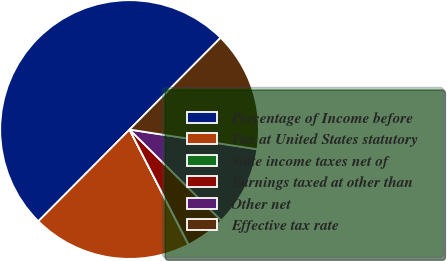Convert chart to OTSL. <chart><loc_0><loc_0><loc_500><loc_500><pie_chart><fcel>Percentage of Income before<fcel>Tax at United States statutory<fcel>State income taxes net of<fcel>Earnings taxed at other than<fcel>Other net<fcel>Effective tax rate<nl><fcel>49.98%<fcel>20.0%<fcel>0.01%<fcel>5.01%<fcel>10.0%<fcel>15.0%<nl></chart> 